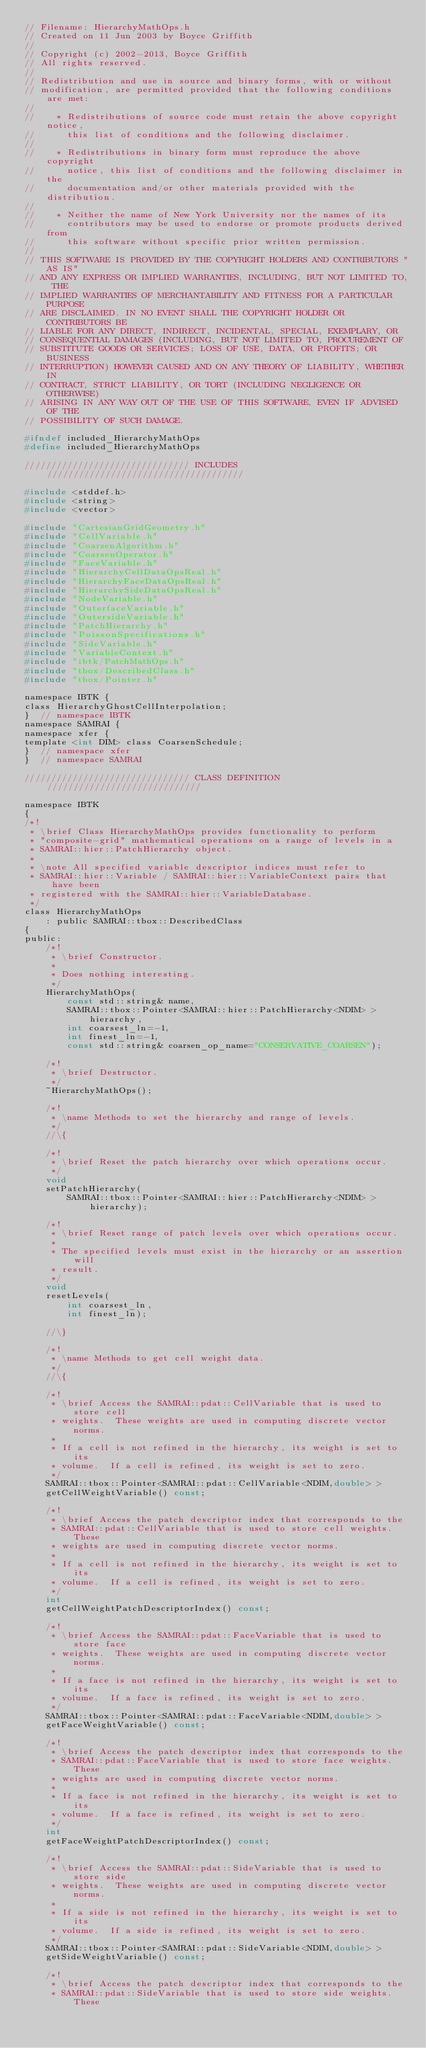Convert code to text. <code><loc_0><loc_0><loc_500><loc_500><_C_>// Filename: HierarchyMathOps.h
// Created on 11 Jun 2003 by Boyce Griffith
//
// Copyright (c) 2002-2013, Boyce Griffith
// All rights reserved.
//
// Redistribution and use in source and binary forms, with or without
// modification, are permitted provided that the following conditions are met:
//
//    * Redistributions of source code must retain the above copyright notice,
//      this list of conditions and the following disclaimer.
//
//    * Redistributions in binary form must reproduce the above copyright
//      notice, this list of conditions and the following disclaimer in the
//      documentation and/or other materials provided with the distribution.
//
//    * Neither the name of New York University nor the names of its
//      contributors may be used to endorse or promote products derived from
//      this software without specific prior written permission.
//
// THIS SOFTWARE IS PROVIDED BY THE COPYRIGHT HOLDERS AND CONTRIBUTORS "AS IS"
// AND ANY EXPRESS OR IMPLIED WARRANTIES, INCLUDING, BUT NOT LIMITED TO, THE
// IMPLIED WARRANTIES OF MERCHANTABILITY AND FITNESS FOR A PARTICULAR PURPOSE
// ARE DISCLAIMED. IN NO EVENT SHALL THE COPYRIGHT HOLDER OR CONTRIBUTORS BE
// LIABLE FOR ANY DIRECT, INDIRECT, INCIDENTAL, SPECIAL, EXEMPLARY, OR
// CONSEQUENTIAL DAMAGES (INCLUDING, BUT NOT LIMITED TO, PROCUREMENT OF
// SUBSTITUTE GOODS OR SERVICES; LOSS OF USE, DATA, OR PROFITS; OR BUSINESS
// INTERRUPTION) HOWEVER CAUSED AND ON ANY THEORY OF LIABILITY, WHETHER IN
// CONTRACT, STRICT LIABILITY, OR TORT (INCLUDING NEGLIGENCE OR OTHERWISE)
// ARISING IN ANY WAY OUT OF THE USE OF THIS SOFTWARE, EVEN IF ADVISED OF THE
// POSSIBILITY OF SUCH DAMAGE.

#ifndef included_HierarchyMathOps
#define included_HierarchyMathOps

/////////////////////////////// INCLUDES /////////////////////////////////////

#include <stddef.h>
#include <string>
#include <vector>

#include "CartesianGridGeometry.h"
#include "CellVariable.h"
#include "CoarsenAlgorithm.h"
#include "CoarsenOperator.h"
#include "FaceVariable.h"
#include "HierarchyCellDataOpsReal.h"
#include "HierarchyFaceDataOpsReal.h"
#include "HierarchySideDataOpsReal.h"
#include "NodeVariable.h"
#include "OuterfaceVariable.h"
#include "OutersideVariable.h"
#include "PatchHierarchy.h"
#include "PoissonSpecifications.h"
#include "SideVariable.h"
#include "VariableContext.h"
#include "ibtk/PatchMathOps.h"
#include "tbox/DescribedClass.h"
#include "tbox/Pointer.h"

namespace IBTK {
class HierarchyGhostCellInterpolation;
}  // namespace IBTK
namespace SAMRAI {
namespace xfer {
template <int DIM> class CoarsenSchedule;
}  // namespace xfer
}  // namespace SAMRAI

/////////////////////////////// CLASS DEFINITION /////////////////////////////

namespace IBTK
{
/*!
 * \brief Class HierarchyMathOps provides functionality to perform
 * "composite-grid" mathematical operations on a range of levels in a
 * SAMRAI::hier::PatchHierarchy object.
 *
 * \note All specified variable descriptor indices must refer to
 * SAMRAI::hier::Variable / SAMRAI::hier::VariableContext pairs that have been
 * registered with the SAMRAI::hier::VariableDatabase.
 */
class HierarchyMathOps
    : public SAMRAI::tbox::DescribedClass
{
public:
    /*!
     * \brief Constructor.
     *
     * Does nothing interesting.
     */
    HierarchyMathOps(
        const std::string& name,
        SAMRAI::tbox::Pointer<SAMRAI::hier::PatchHierarchy<NDIM> > hierarchy,
        int coarsest_ln=-1,
        int finest_ln=-1,
        const std::string& coarsen_op_name="CONSERVATIVE_COARSEN");

    /*!
     * \brief Destructor.
     */
    ~HierarchyMathOps();

    /*!
     * \name Methods to set the hierarchy and range of levels.
     */
    //\{

    /*!
     * \brief Reset the patch hierarchy over which operations occur.
     */
    void
    setPatchHierarchy(
        SAMRAI::tbox::Pointer<SAMRAI::hier::PatchHierarchy<NDIM> > hierarchy);

    /*!
     * \brief Reset range of patch levels over which operations occur.
     *
     * The specified levels must exist in the hierarchy or an assertion will
     * result.
     */
    void
    resetLevels(
        int coarsest_ln,
        int finest_ln);

    //\}

    /*!
     * \name Methods to get cell weight data.
     */
    //\{

    /*!
     * \brief Access the SAMRAI::pdat::CellVariable that is used to store cell
     * weights.  These weights are used in computing discrete vector norms.
     *
     * If a cell is not refined in the hierarchy, its weight is set to its
     * volume.  If a cell is refined, its weight is set to zero.
     */
    SAMRAI::tbox::Pointer<SAMRAI::pdat::CellVariable<NDIM,double> >
    getCellWeightVariable() const;

    /*!
     * \brief Access the patch descriptor index that corresponds to the
     * SAMRAI::pdat::CellVariable that is used to store cell weights.  These
     * weights are used in computing discrete vector norms.
     *
     * If a cell is not refined in the hierarchy, its weight is set to its
     * volume.  If a cell is refined, its weight is set to zero.
     */
    int
    getCellWeightPatchDescriptorIndex() const;

    /*!
     * \brief Access the SAMRAI::pdat::FaceVariable that is used to store face
     * weights.  These weights are used in computing discrete vector norms.
     *
     * If a face is not refined in the hierarchy, its weight is set to its
     * volume.  If a face is refined, its weight is set to zero.
     */
    SAMRAI::tbox::Pointer<SAMRAI::pdat::FaceVariable<NDIM,double> >
    getFaceWeightVariable() const;

    /*!
     * \brief Access the patch descriptor index that corresponds to the
     * SAMRAI::pdat::FaceVariable that is used to store face weights.  These
     * weights are used in computing discrete vector norms.
     *
     * If a face is not refined in the hierarchy, its weight is set to its
     * volume.  If a face is refined, its weight is set to zero.
     */
    int
    getFaceWeightPatchDescriptorIndex() const;

    /*!
     * \brief Access the SAMRAI::pdat::SideVariable that is used to store side
     * weights.  These weights are used in computing discrete vector norms.
     *
     * If a side is not refined in the hierarchy, its weight is set to its
     * volume.  If a side is refined, its weight is set to zero.
     */
    SAMRAI::tbox::Pointer<SAMRAI::pdat::SideVariable<NDIM,double> >
    getSideWeightVariable() const;

    /*!
     * \brief Access the patch descriptor index that corresponds to the
     * SAMRAI::pdat::SideVariable that is used to store side weights.  These</code> 